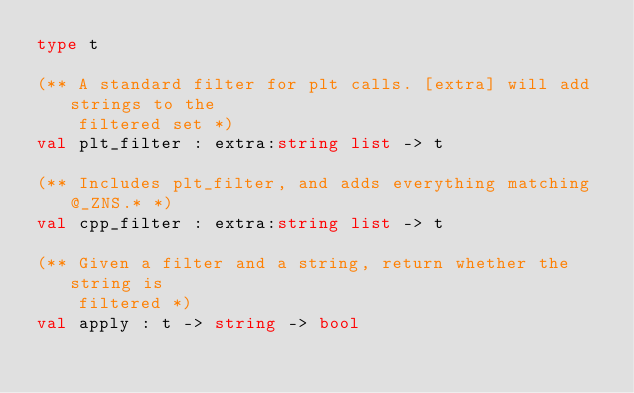<code> <loc_0><loc_0><loc_500><loc_500><_OCaml_>type t

(** A standard filter for plt calls. [extra] will add strings to the
    filtered set *)
val plt_filter : extra:string list -> t

(** Includes plt_filter, and adds everything matching @_ZNS.* *)
val cpp_filter : extra:string list -> t

(** Given a filter and a string, return whether the string is
    filtered *)
val apply : t -> string -> bool
</code> 